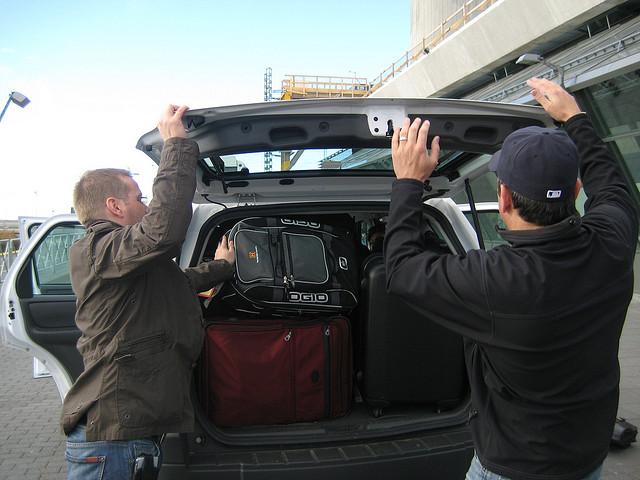Will they be able to close the door what with everything in the trunk?
Answer briefly. Yes. What color is the suitcase that the man has his hands on?
Answer briefly. Black. Which person has a ball cap on?
Keep it brief. Right. Is a man in the military?
Keep it brief. No. Sunny or overcast?
Keep it brief. Sunny. 